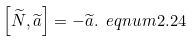<formula> <loc_0><loc_0><loc_500><loc_500>\left [ \widetilde { N } , \widetilde { a } \right ] = - \widetilde { a } . \ e q n u m { 2 . 2 4 }</formula> 